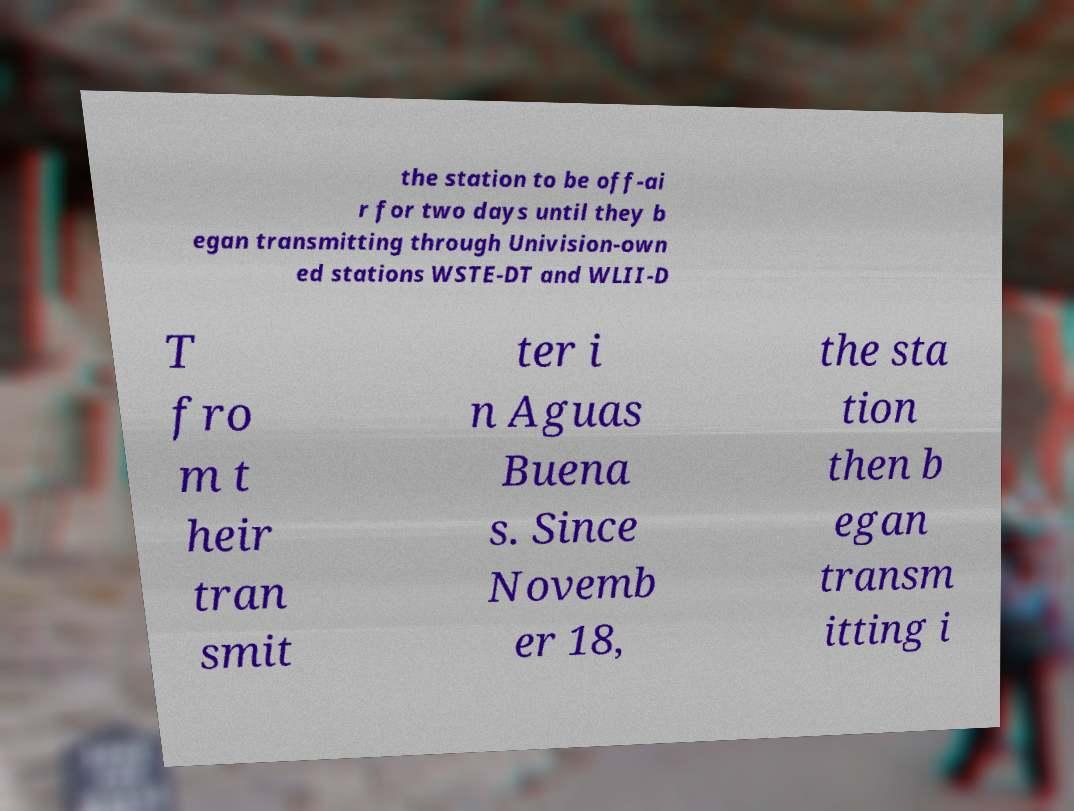Please read and relay the text visible in this image. What does it say? the station to be off-ai r for two days until they b egan transmitting through Univision-own ed stations WSTE-DT and WLII-D T fro m t heir tran smit ter i n Aguas Buena s. Since Novemb er 18, the sta tion then b egan transm itting i 